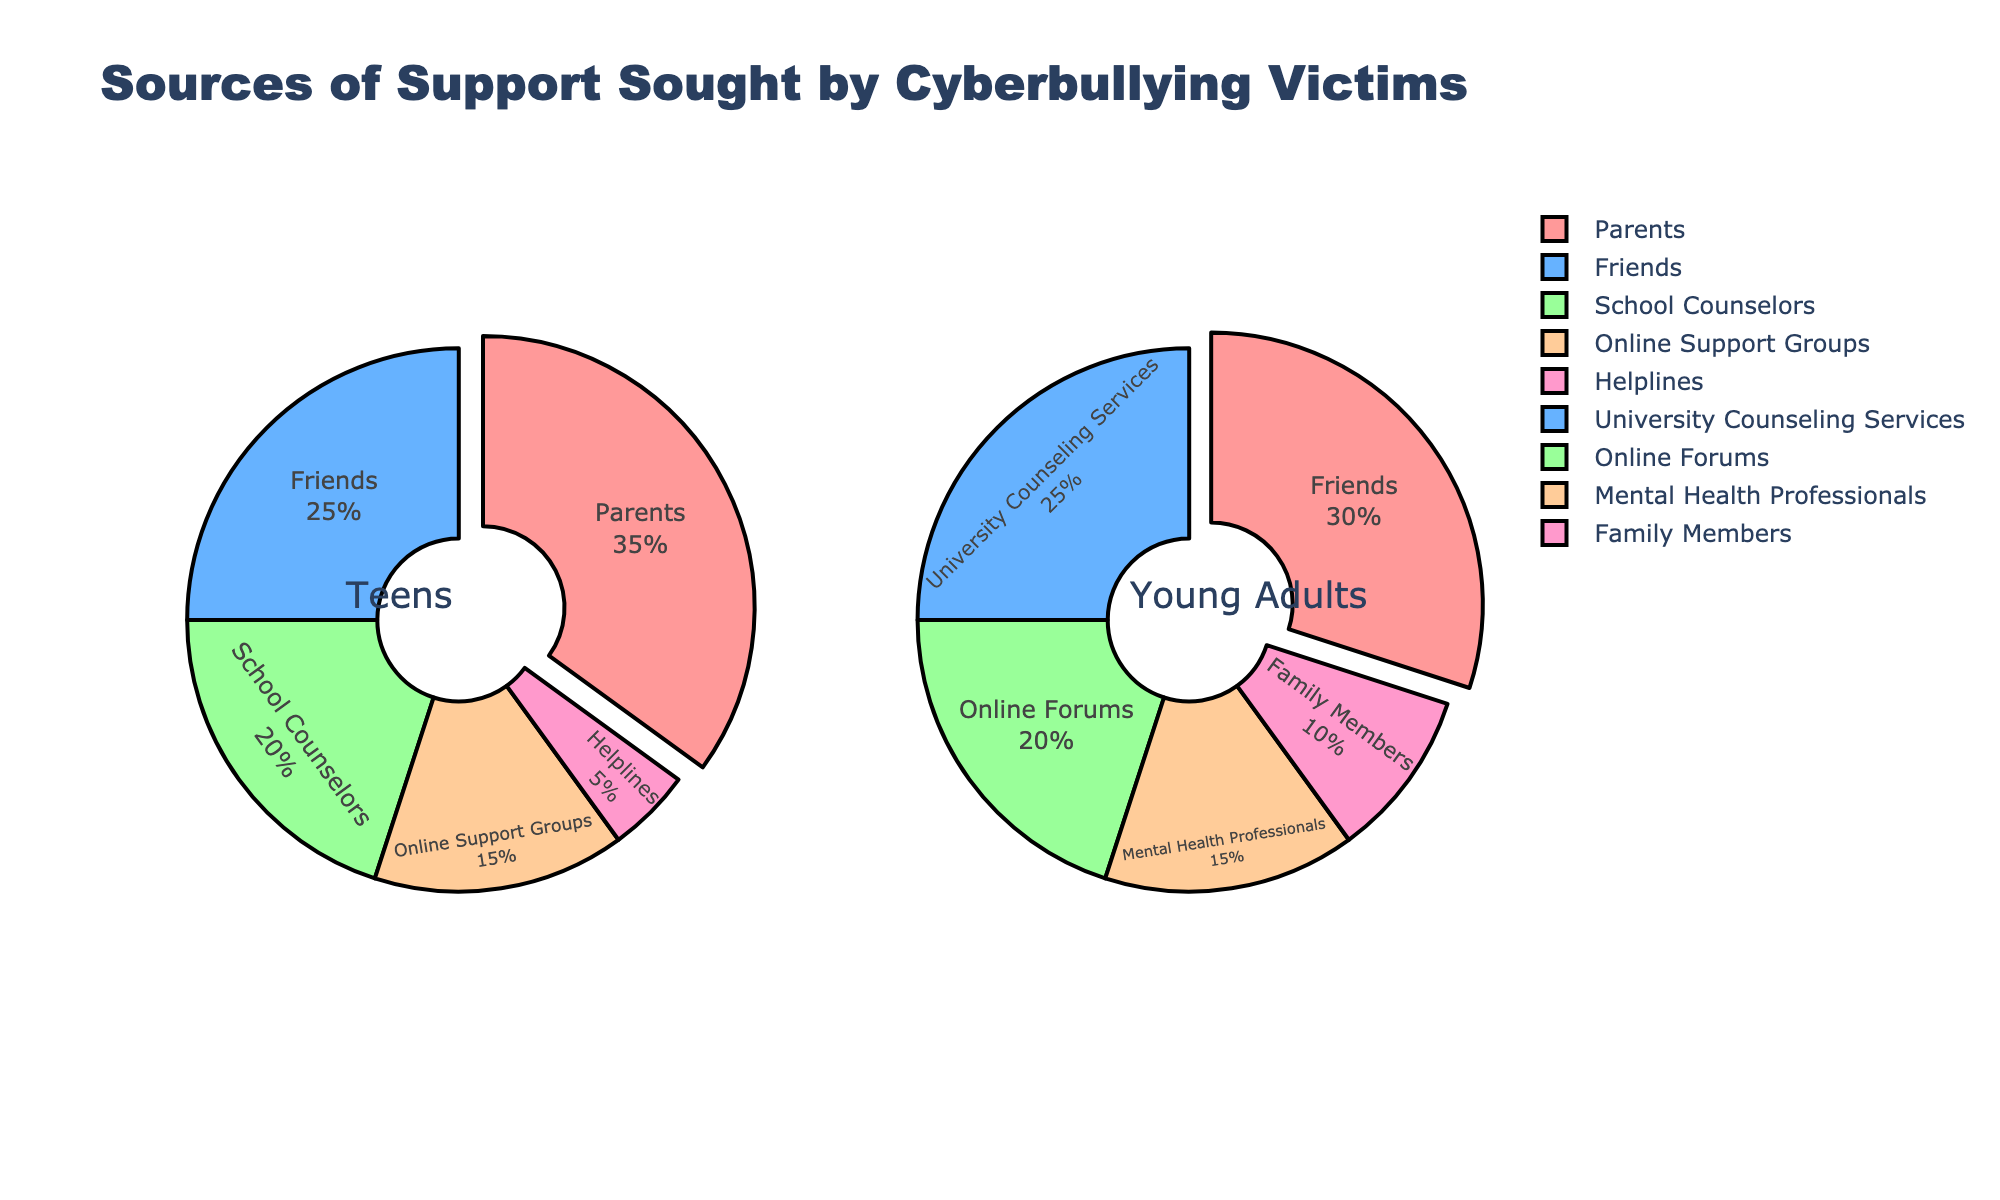What's the title of the plot? The title of the plot is "Breakdown of Rare Wine Bottle Sales by Vintage Year at Major Auctions", which is displayed at the top of the figure.
Answer: Breakdown of Rare Wine Bottle Sales by Vintage Year at Major Auctions Which region has the largest share of sales for the 2000 vintage? For the 2000 vintage, Bordeaux has the largest share with a noticeable portion of the pie chart dedicated to it.
Answer: Bordeaux How many different vintage years are displayed in the figure? There are 6 different vintage years displayed, as indicated by the subplot titles: 1982, 1990, 1995, 2000, 2005, and 2010.
Answer: 6 Which vintage year has the highest percentage of Burgundy sales? In the figure, 2010 shows the highest percentage of Burgundy sales, marked by a large segment in that pie chart.
Answer: 2010 What is the combined percentage of Bordeaux and Burgundy sales for the 1982 vintage? In the pie chart for 1982, Bordeaux represents 35% and Burgundy represents 20%. Adding these together: 35% + 20% = 55%.
Answer: 55% Is the percentage of Champagne sales higher for the 2000 vintage or the 2005 vintage? The Champagne percentage for the 2000 vintage is 20%, while for the 2005 vintage it is 10%. Thus, it is higher in the 2000 vintage.
Answer: 2000 vintage Which vintage has the least share of "Other" region sales? The pie chart for 2000 vintage shows the least share of "Other" region sales with only 10%.
Answer: 2000 How do the percentages of Italian wine sales change from 1990 to 2010? In 1990, Italian wine sales are 20%. In 2010, they increase to 30%. Therefore, there is an increase of 10%.
Answer: Increase by 10% Which two regions dominate the sales share in the 2010 vintage? In the 2010 vintage pie chart, Burgundy and Italian dominate the sales share, each having substantial portions compared to other regions.
Answer: Burgundy and Italian Is the share of Bordeaux wine sales consistent across all vintages? No, the share of Bordeaux wine sales varies across the vintages, ranging from a high in 2000 (40%) to a low in 2010 (15%).
Answer: No 